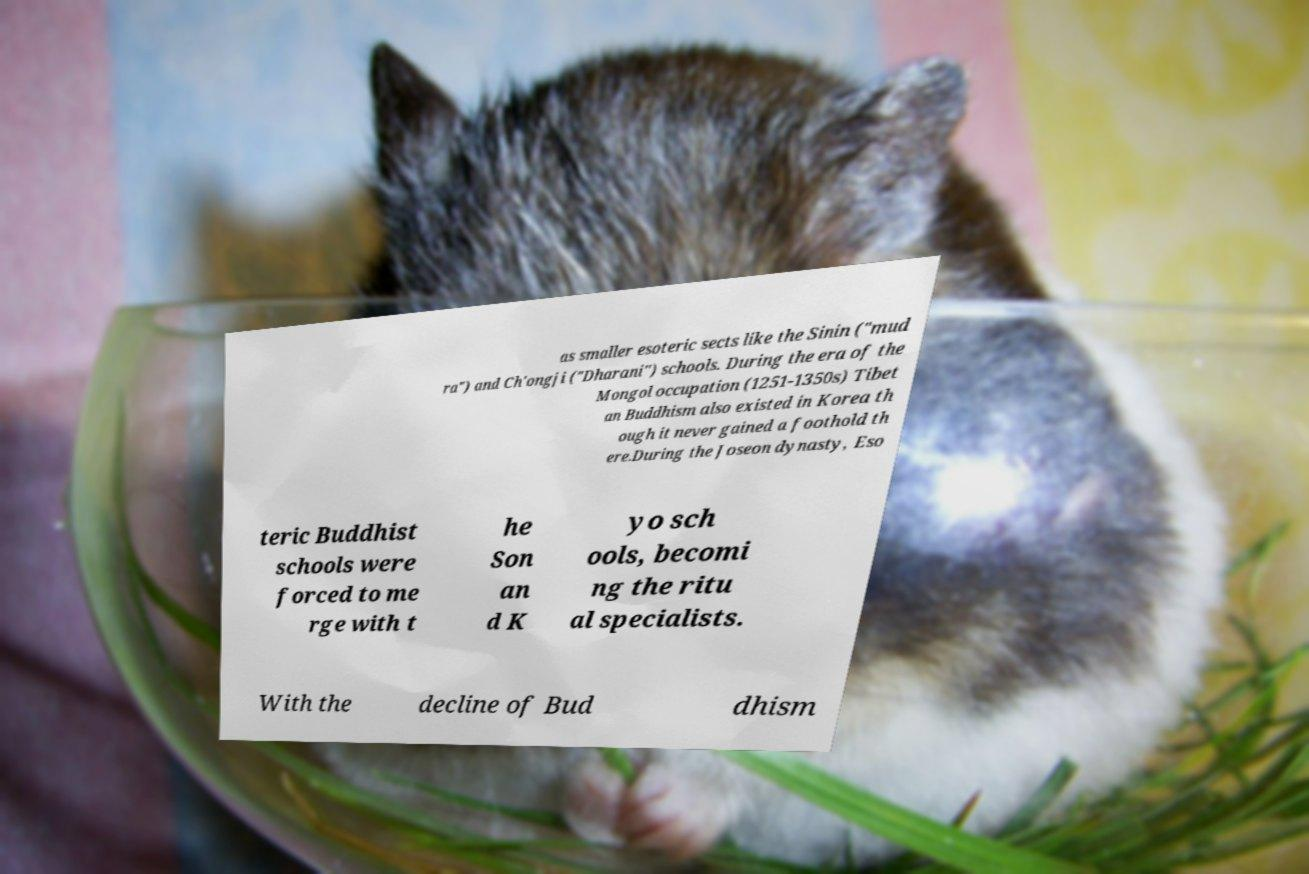I need the written content from this picture converted into text. Can you do that? as smaller esoteric sects like the Sinin ("mud ra") and Ch'ongji ("Dharani") schools. During the era of the Mongol occupation (1251-1350s) Tibet an Buddhism also existed in Korea th ough it never gained a foothold th ere.During the Joseon dynasty, Eso teric Buddhist schools were forced to me rge with t he Son an d K yo sch ools, becomi ng the ritu al specialists. With the decline of Bud dhism 